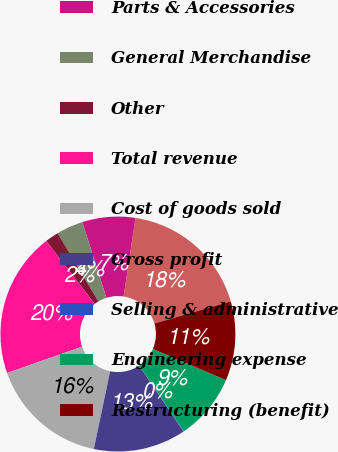Convert chart. <chart><loc_0><loc_0><loc_500><loc_500><pie_chart><fcel>Motorcycles<fcel>Parts & Accessories<fcel>General Merchandise<fcel>Other<fcel>Total revenue<fcel>Cost of goods sold<fcel>Gross profit<fcel>Selling & administrative<fcel>Engineering expense<fcel>Restructuring (benefit)<nl><fcel>18.13%<fcel>7.29%<fcel>3.67%<fcel>1.87%<fcel>19.94%<fcel>16.33%<fcel>12.71%<fcel>0.06%<fcel>9.1%<fcel>10.9%<nl></chart> 